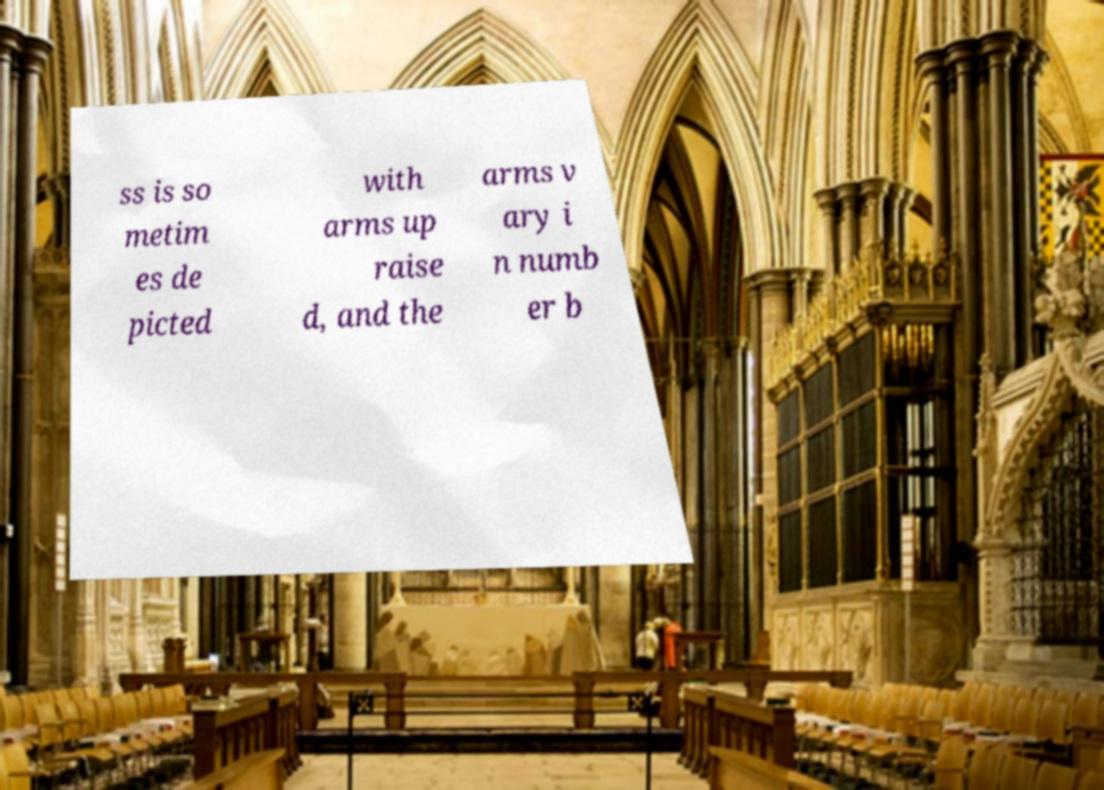What messages or text are displayed in this image? I need them in a readable, typed format. ss is so metim es de picted with arms up raise d, and the arms v ary i n numb er b 